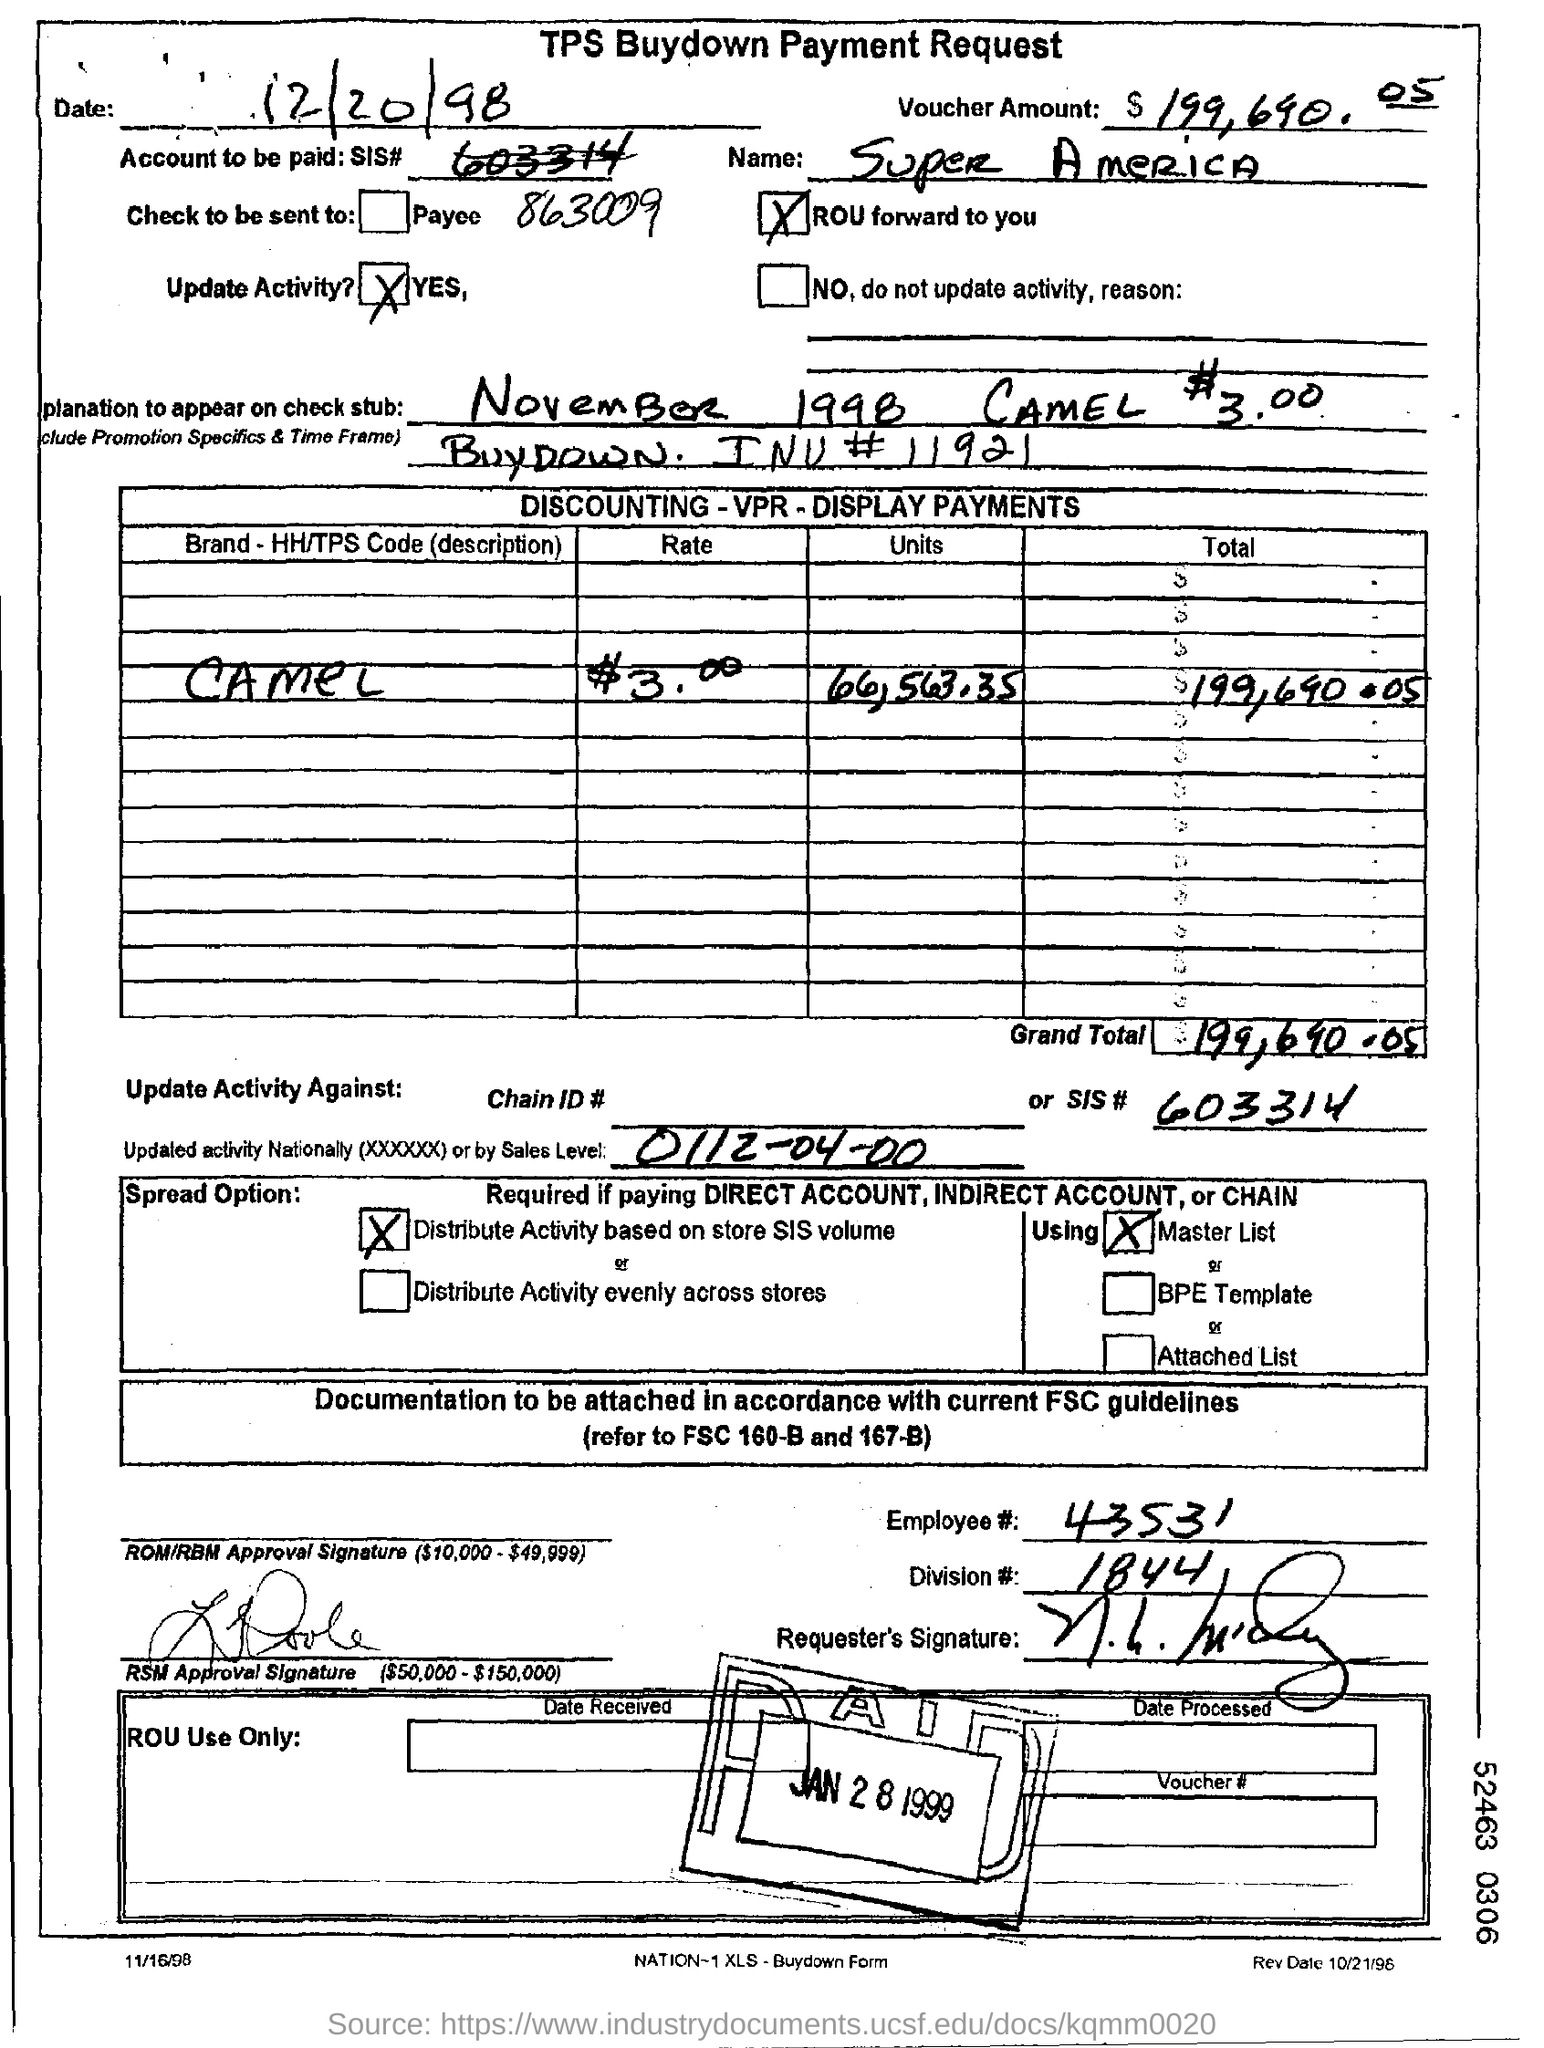What is the heading of the document?
Make the answer very short. TPS Buydown Payment Request. What is the date mentioned?
Make the answer very short. 12/20/98. What is the employee#(no) mentioned in the form?
Give a very brief answer. 43531. Which Brand is mentioned in the table?
Give a very brief answer. Camel. 